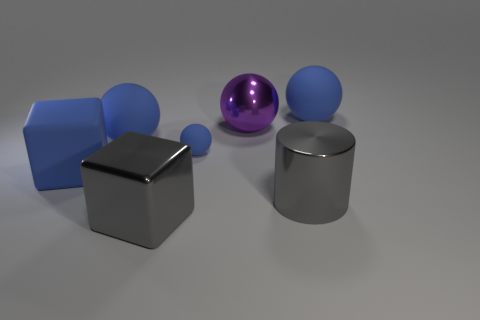What number of balls have the same color as the small rubber thing?
Your answer should be compact. 2. Is the large rubber cube the same color as the tiny object?
Your response must be concise. Yes. Are there the same number of large blue rubber objects that are left of the gray shiny block and large purple spheres in front of the purple thing?
Give a very brief answer. No. There is a big shiny cylinder right of the large blue sphere left of the matte sphere that is on the right side of the purple shiny thing; what is its color?
Your response must be concise. Gray. Is there any other thing that has the same color as the large metal sphere?
Keep it short and to the point. No. There is a object that is the same color as the metallic block; what shape is it?
Ensure brevity in your answer.  Cylinder. What size is the gray thing that is behind the large gray shiny cube?
Make the answer very short. Large. The purple thing that is the same size as the gray cylinder is what shape?
Provide a short and direct response. Sphere. Is the material of the large gray object that is behind the gray shiny block the same as the gray object to the left of the tiny rubber ball?
Keep it short and to the point. Yes. There is a big gray object that is to the right of the block in front of the large blue matte cube; what is its material?
Your answer should be very brief. Metal. 